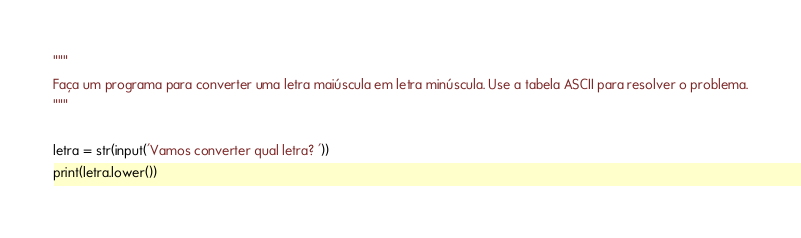<code> <loc_0><loc_0><loc_500><loc_500><_Python_>"""
Faça um programa para converter uma letra maiúscula em letra minúscula. Use a tabela ASCII para resolver o problema.
"""

letra = str(input('Vamos converter qual letra? '))
print(letra.lower())
</code> 